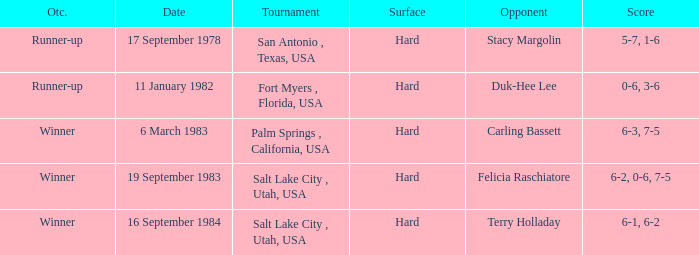What was the outcome of the match against Stacy Margolin? Runner-up. 